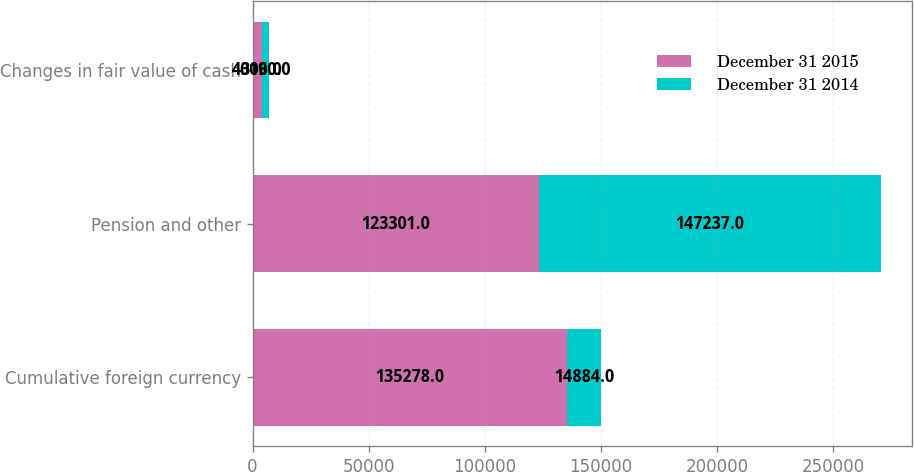<chart> <loc_0><loc_0><loc_500><loc_500><stacked_bar_chart><ecel><fcel>Cumulative foreign currency<fcel>Pension and other<fcel>Changes in fair value of cash<nl><fcel>December 31 2015<fcel>135278<fcel>123301<fcel>4006<nl><fcel>December 31 2014<fcel>14884<fcel>147237<fcel>3190<nl></chart> 